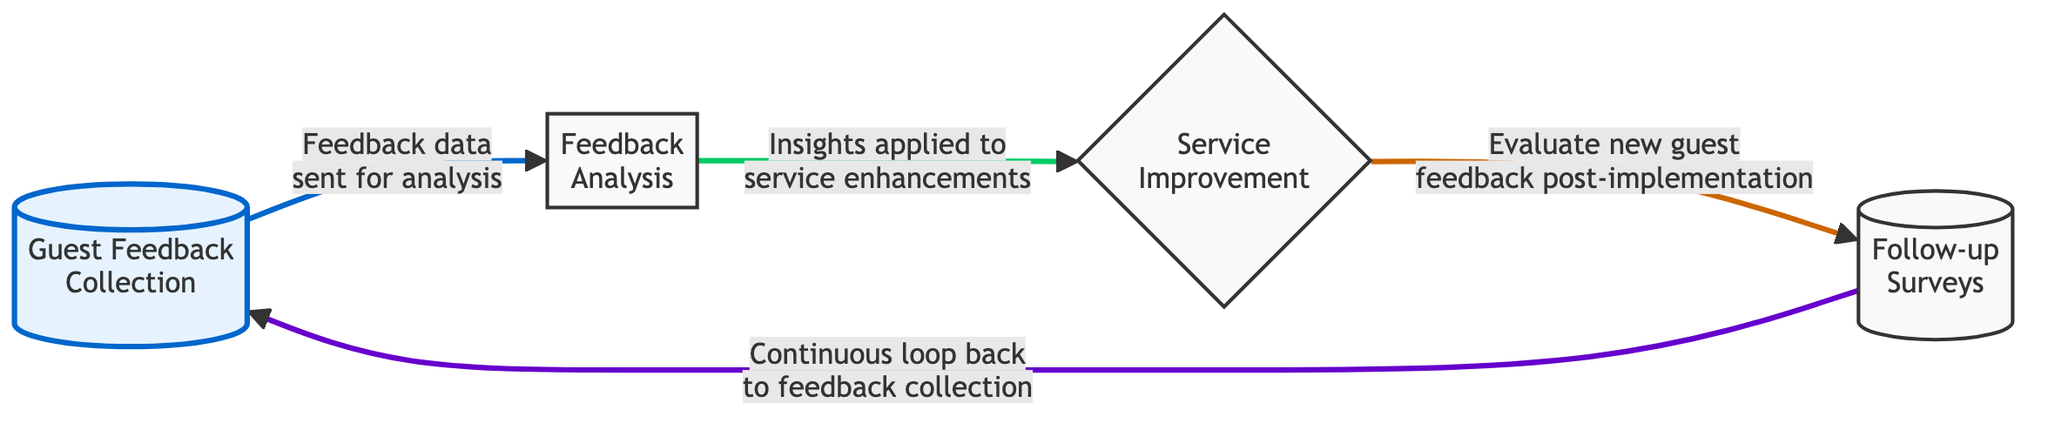What is the first step in the feedback loop? The diagram indicates that the first step in the feedback loop is "Guest Feedback Collection," which is the starting point for gathering data.
Answer: Guest Feedback Collection What node comes after "Feedback Analysis"? According to the flow of the diagram, the node that follows "Feedback Analysis" is "Service Improvement," where insights from the analysis are applied.
Answer: Service Improvement How many nodes are in the diagram? The diagram contains four distinct nodes representing different stages of the feedback loop: Guest Feedback Collection, Feedback Analysis, Service Improvement, and Follow-up Surveys.
Answer: Four Which node initiates the continuous loop? The continuous loop is initiated by the "Follow-up Surveys" node, which sends feedback back to "Guest Feedback Collection" to begin the process again.
Answer: Follow-up Surveys What type of feedback is sent for analysis? The diagram specifies that "Feedback data" is sent for analysis, indicating it is the information collected from guests.
Answer: Feedback data What action follows "Evaluate new guest feedback post-implementation"? The next action after "Evaluate new guest feedback post-implementation" is to conduct "Follow-up Surveys," indicating reassessment of guest satisfaction.
Answer: Follow-up Surveys What color represents the active node in the diagram? The active node is highlighted in light blue fill ("#e6f3ff"), distinguishing it from the default nodes in the diagram.
Answer: Light blue If there is no guest feedback, what happens to the loop? If there is no guest feedback, the loop would not progress beyond "Guest Feedback Collection," indicating the whole process would stall.
Answer: Stalls What is the purpose of "Insights applied to service enhancements"? The purpose of this step is to implement the findings from the feedback analysis to improve guest services based on the insights gained.
Answer: Service improvements 